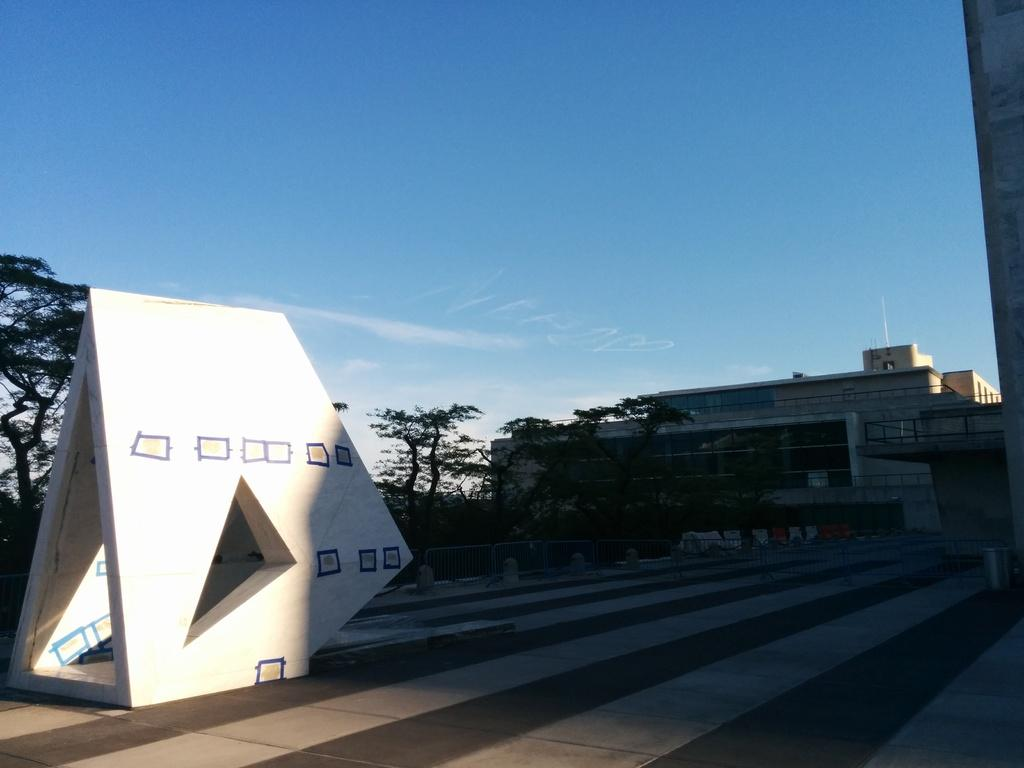What type of natural vegetation is visible in the image? There are trees in the image. What type of man-made structure can be seen in the image? There is a building in the image. What is the artistic feature in the image? There is a sculpture in the image. What is visible at the top of the image? The sky is visible in the image. What can be seen in the sky in the image? There are clouds in the image. What type of cream can be seen being applied to the wheel in the image? There is no wheel or cream present in the image. What season is depicted in the image, considering the presence of trees and clouds? The image does not provide enough information to determine the season. 